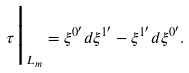<formula> <loc_0><loc_0><loc_500><loc_500>\tau \Big | _ { L _ { m } } = \xi ^ { 0 ^ { \prime } } d \xi ^ { 1 ^ { \prime } } - \xi ^ { 1 ^ { \prime } } d \xi ^ { 0 ^ { \prime } } .</formula> 